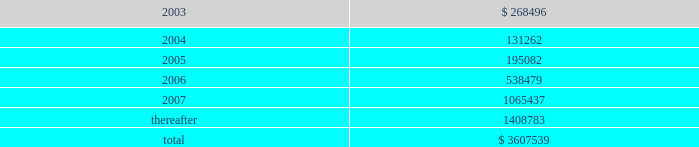American tower corporation and subsidiaries notes to consolidated financial statements 2014 ( continued ) 19 .
Subsequent events 12.25% ( 12.25 % ) senior subordinated discount notes and warrants offering 2014in january 2003 , the company issued 808000 units , each consisting of ( 1 ) $ 1000 principal amount at maturity of the 12.25% ( 12.25 % ) senior subordinated discount notes due 2008 of a wholly owned subsidiary of the company ( ati notes ) and ( 2 ) a warrant to purchase 14.0953 shares of class a common stock of the company , for gross proceeds of $ 420.0 million .
The gross offering proceeds were allocated between the ati notes ( $ 367.4 million ) and the fair value of the warrants ( $ 52.6 million ) .
Net proceeds from the offering aggregated approximately $ 397.0 million and were or will be used for the purposes described below under amended and restated loan agreement .
The ati notes accrue no cash interest .
Instead , the accreted value of each ati note will increase between the date of original issuance and maturity ( august 1 , 2008 ) at a rate of 12.25% ( 12.25 % ) per annum .
The 808000 warrants that were issued together with the ati notes each represent the right to purchase 14.0953 shares of class a common stock at $ 0.01 per share .
The warrants are exercisable at any time on or after january 29 , 2006 and will expire on august 1 , 2008 .
As of the issuance date , the warrants represented approximately 5.5% ( 5.5 % ) of the company 2019s outstanding common stock ( assuming exercise of all warrants ) .
The indenture governing the ati notes contains covenants that , among other things , limit the ability of the issuer subsidiary and its guarantors to incur or guarantee additional indebtedness , create liens , pay dividends or make other equity distributions , enter into agreements restricting the restricted subsidiaries 2019 ability to pay dividends , purchase or redeem capital stock , make investments and sell assets or consolidate or merge with or into other companies .
The ati notes rank junior in right of payment to all existing and future senior indebtedness , including all indebtedness outstanding under the credit facilities , and are structurally senior in right of payment to all existing and future indebtedness of the company .
Amended and restated loan agreement 2014on february 21 , 2003 , the company completed an amendment to its credit facilities .
The amendment provides for the following : 2022 prepayment of a portion of outstanding term loans .
The company agreed to prepay an aggregate of $ 200.0 million of the term loans outstanding under the credit facilities from a portion of the net proceeds of the ati notes offering completed in january 2003 .
This prepayment consisted of a $ 125.0 million prepayment of the term loan a and a $ 75.0 million prepayment of the term loan b , each to be applied to reduce future scheduled principal payments .
Giving effect to the prepayment of $ 200.0 million of term loans under the credit facility and the issuance of the ati notes as discussed above as well as the paydown of debt from net proceeds of the sale of mtn ( $ 24.5 million in february 2003 ) , the company 2019s aggregate principal payments of long- term debt , including capital leases , for the next five years and thereafter are as follows ( in thousands ) : year ending december 31 .

Of the amount agreed by the company for the prepayment on the term loans what was the percentage for the term loan a? 
Computations: (75.0 / 200.0)
Answer: 0.375. 